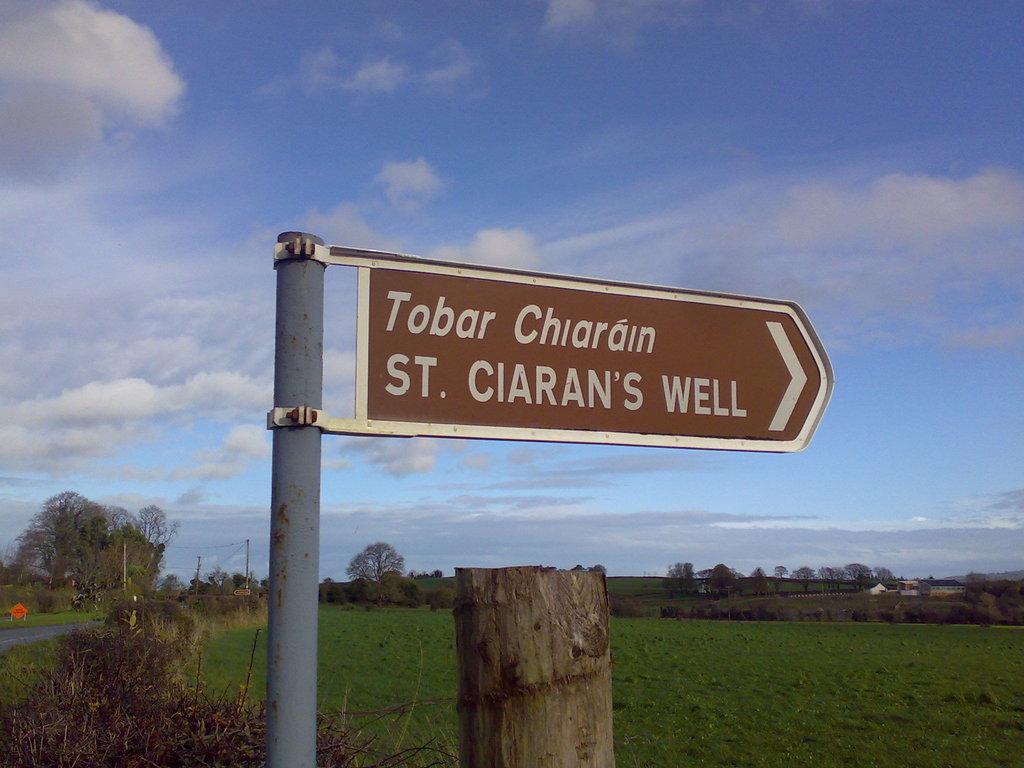Could you give a brief overview of what you see in this image? In this image we can see a pole with a sign board. On that something is written. There is a wooden pole. On the ground there is grass. Also there are trees. In the background there is sky with clouds. 